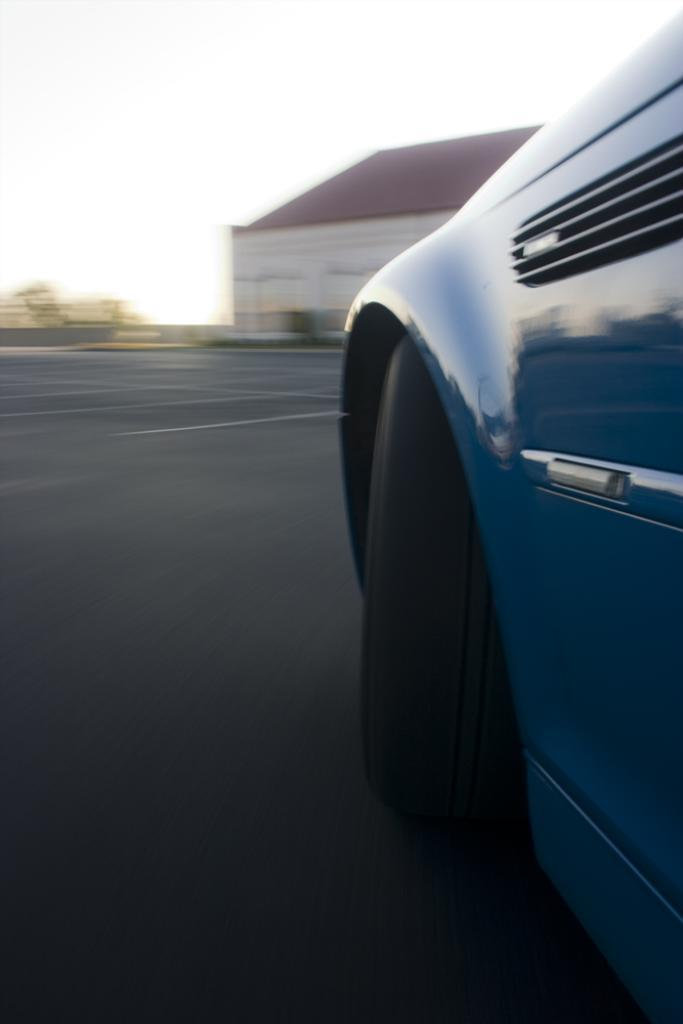What is the main subject in the front of the image? There is a car in the front of the image. What can be seen in the background of the image? There is a house in the background of the image. What color are the objects on the left side of the image? The objects on the left side of the image are green in color. How many vests can be seen hanging on the line in the image? There is no line or vest present in the image. 